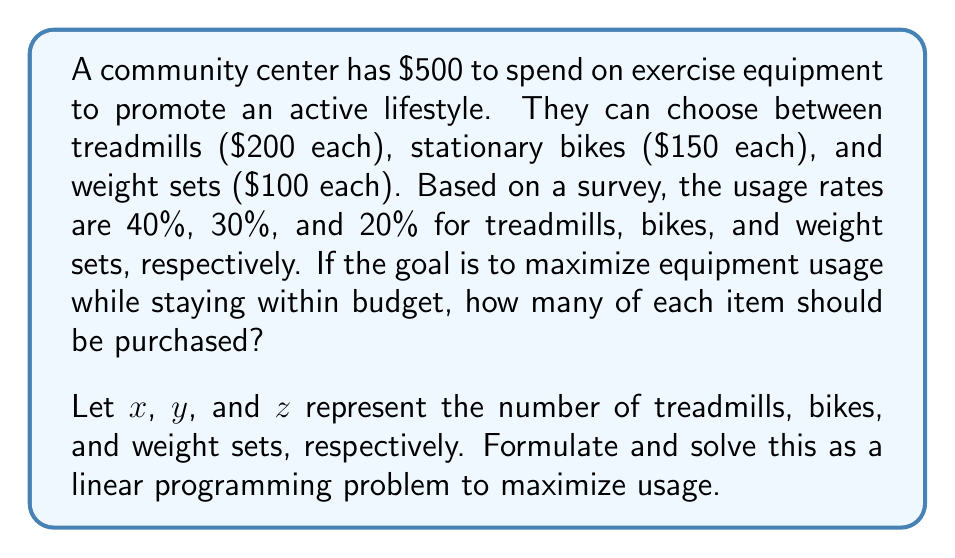Can you answer this question? To solve this optimization problem, we'll follow these steps:

1) Define the objective function:
   Maximize usage = $0.4x + 0.3y + 0.2z$

2) Define the constraints:
   Budget constraint: $200x + 150y + 100z \leq 500$
   Non-negativity: $x, y, z \geq 0$ and integer

3) Set up the linear programming problem:
   
   Maximize: $0.4x + 0.3y + 0.2z$
   Subject to:
   $200x + 150y + 100z \leq 500$
   $x, y, z \geq 0$ and integer

4) Solve using the simplex method or graphical method. However, since we need integer solutions, we'll use a branch and bound approach or check all feasible integer combinations.

5) Feasible integer combinations:
   (2,0,1): Usage = 0.8 + 0 + 0.2 = 1.0
   (1,2,0): Usage = 0.4 + 0.6 + 0 = 1.0
   (0,3,0): Usage = 0 + 0.9 + 0 = 0.9
   (1,1,1): Usage = 0.4 + 0.3 + 0.2 = 0.9
   (0,2,2): Usage = 0 + 0.6 + 0.4 = 1.0

6) The maximum usage is 1.0, which can be achieved by three different combinations: (2,0,1), (1,2,0), or (0,2,2).

7) From a nursing perspective, promoting a variety of exercise types is beneficial for overall health. Therefore, the optimal solution would be (0,2,2), which provides a mix of cardio and strength training equipment.
Answer: The optimal distribution is 0 treadmills, 2 stationary bikes, and 2 weight sets, maximizing usage at 1.0 (or 100%) while providing a variety of exercise options. 